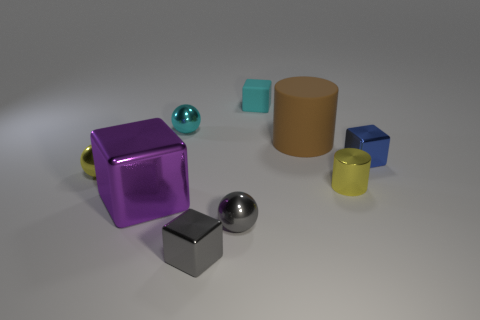Subtract all gray blocks. How many blocks are left? 3 Subtract all green blocks. Subtract all gray balls. How many blocks are left? 4 Subtract all cylinders. How many objects are left? 7 Add 4 small purple rubber cubes. How many small purple rubber cubes exist? 4 Subtract 1 gray spheres. How many objects are left? 8 Subtract all cylinders. Subtract all brown cylinders. How many objects are left? 6 Add 7 yellow metal cylinders. How many yellow metal cylinders are left? 8 